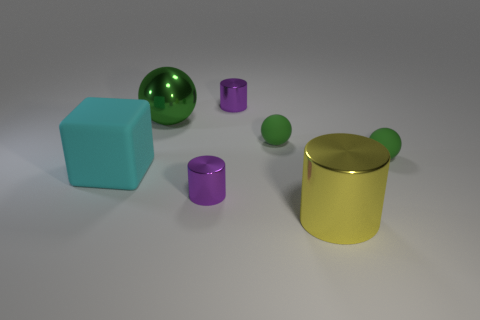Subtract all tiny purple cylinders. How many cylinders are left? 1 Add 1 big green metallic balls. How many objects exist? 8 Subtract 1 balls. How many balls are left? 2 Subtract all cubes. How many objects are left? 6 Add 6 small yellow metallic cylinders. How many small yellow metallic cylinders exist? 6 Subtract 1 yellow cylinders. How many objects are left? 6 Subtract all tiny gray rubber cylinders. Subtract all large cubes. How many objects are left? 6 Add 7 green rubber spheres. How many green rubber spheres are left? 9 